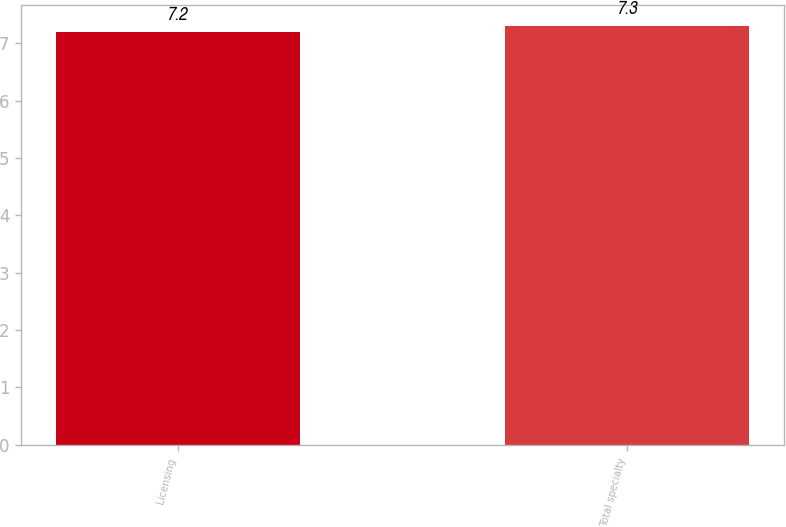Convert chart. <chart><loc_0><loc_0><loc_500><loc_500><bar_chart><fcel>Licensing<fcel>Total specialty<nl><fcel>7.2<fcel>7.3<nl></chart> 